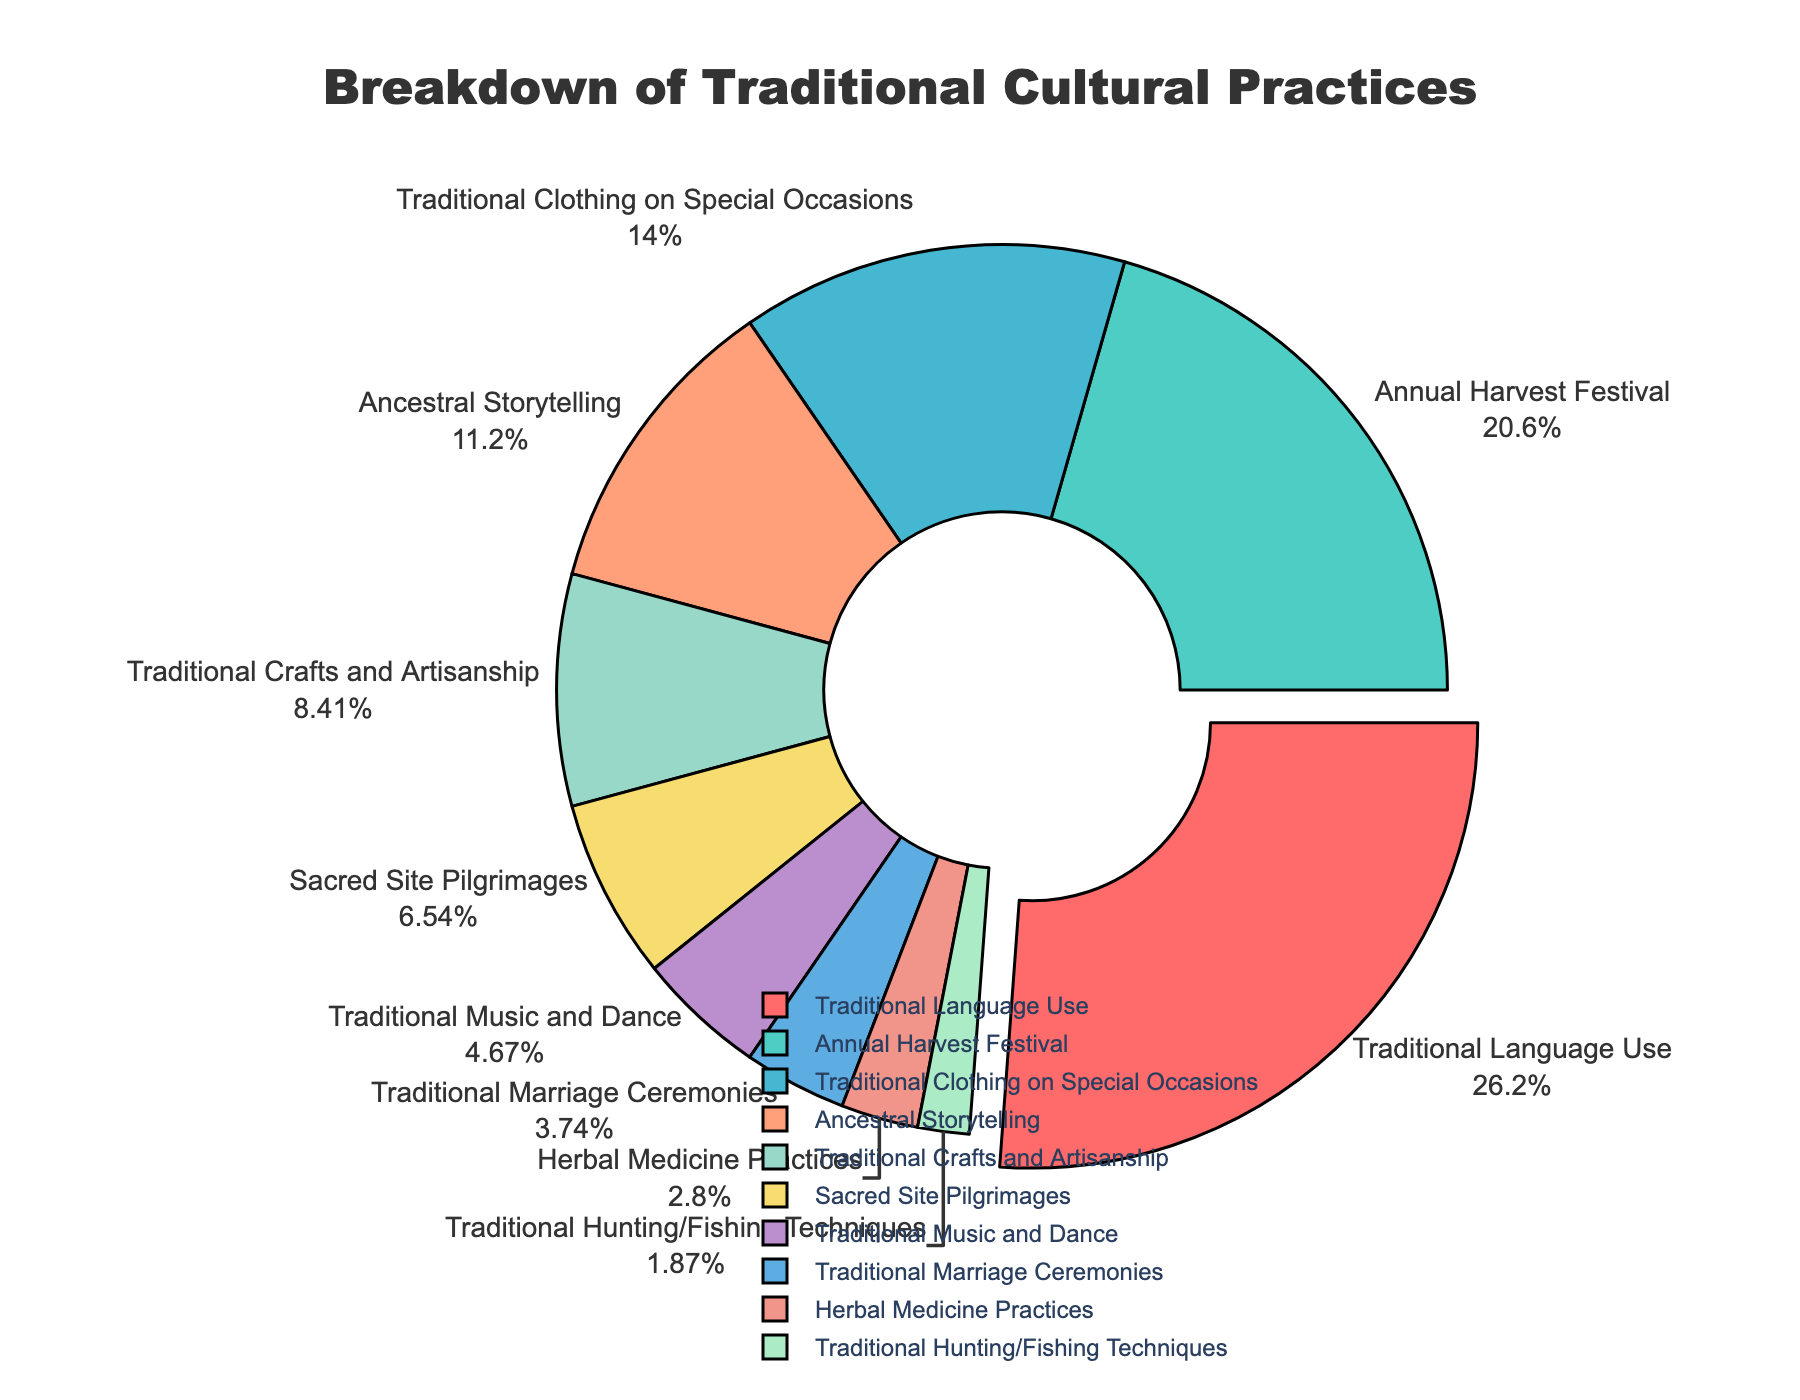What percent of cultural practices are represented by "Ancestral Storytelling" and "Traditional Music and Dance" combined? The percentages for "Ancestral Storytelling" and "Traditional Music and Dance" are 12% and 5%, respectively. Adding these together gives 12 + 5 = 17%.
Answer: 17% Which cultural practice is observed the most? The largest slice of the pie, indicated by being pulled out slightly, represents "Traditional Language Use" at 28%.
Answer: Traditional Language Use How many cultural practices are observed by less than 10% of the community? The pie chart has five slices representing practices with percentages less than 10%: Traditional Crafts and Artisanship (9%), Sacred Site Pilgrimages (7%), Traditional Music and Dance (5%), Traditional Marriage Ceremonies (4%), Herbal Medicine Practices (3%), and Traditional Hunting/Fishing Techniques (2%). There are 6 practices in total.
Answer: 6 What is the difference in percentage between the practice of "Annual Harvest Festival" and "Traditional Clothing on Special Occasions"? "Annual Harvest Festival" has 22% and "Traditional Clothing on Special Occasions" has 15%. The difference is 22 - 15 = 7%.
Answer: 7% Which cultural practice has the smallest representation in the community? The smallest slice of the pie chart represents "Traditional Hunting/Fishing Techniques" at 2%.
Answer: Traditional Hunting/Fishing Techniques How does the percentage of "Sacred Site Pilgrimages" compare to "Traditional Crafts and Artisanship"? "Sacred Site Pilgrimages" is 7% and "Traditional Crafts and Artisanship" is 9%. Therefore, "Sacred Site Pilgrimages" is 2% less than "Traditional Crafts and Artisanship".
Answer: Sacred Site Pilgrimages is 2% less What percentage of the community observes both "Traditional Language Use" and "Annual Harvest Festival"? The percentages for "Traditional Language Use" and "Annual Harvest Festival" are 28% and 22%, respectively. Combining these gives 28 + 22 = 50%.
Answer: 50% Which two practices together make up more than one-third of the pie chart? "Traditional Language Use" represents 28% and "Annual Harvest Festival" represents 22%. Together, they make up 28 + 22 = 50%, which is more than one-third (33.33%) of the pie.
Answer: Traditional Language Use and Annual Harvest Festival 